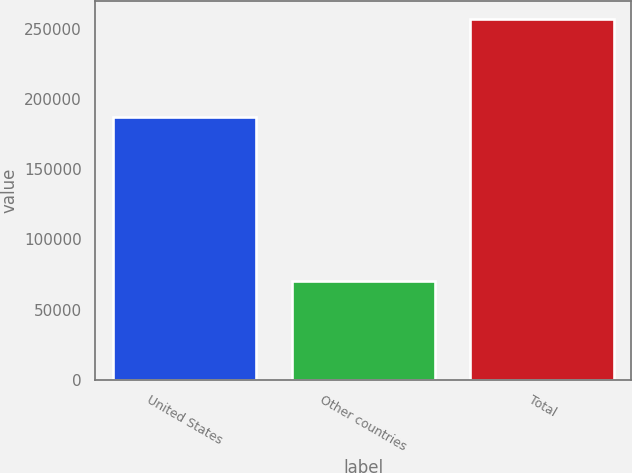Convert chart to OTSL. <chart><loc_0><loc_0><loc_500><loc_500><bar_chart><fcel>United States<fcel>Other countries<fcel>Total<nl><fcel>186854<fcel>70181<fcel>257035<nl></chart> 